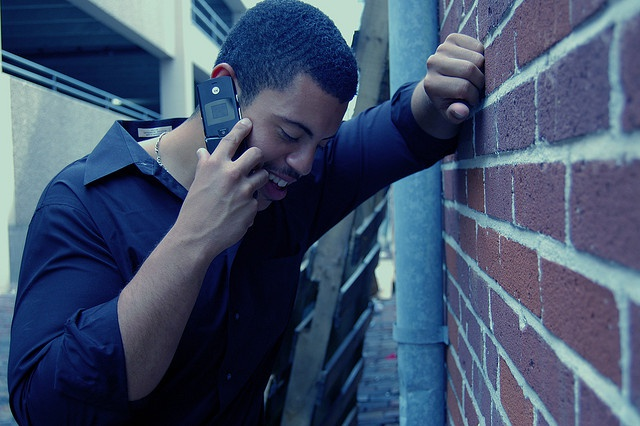Describe the objects in this image and their specific colors. I can see people in black, navy, gray, and darkgray tones and cell phone in black, blue, navy, and teal tones in this image. 